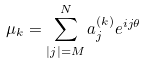Convert formula to latex. <formula><loc_0><loc_0><loc_500><loc_500>\mu _ { k } = \sum _ { | j | = M } ^ { N } a _ { j } ^ { ( k ) } e ^ { i j \theta }</formula> 